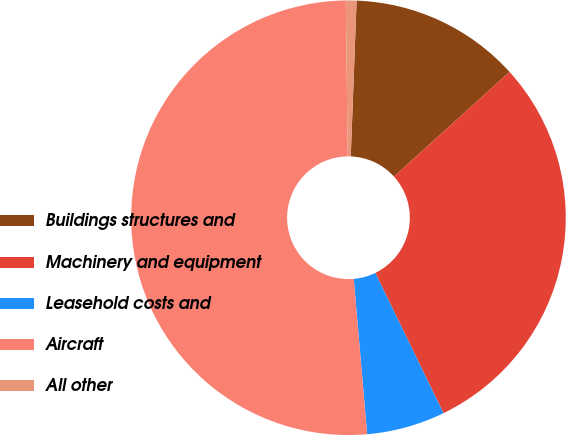<chart> <loc_0><loc_0><loc_500><loc_500><pie_chart><fcel>Buildings structures and<fcel>Machinery and equipment<fcel>Leasehold costs and<fcel>Aircraft<fcel>All other<nl><fcel>12.69%<fcel>29.51%<fcel>5.83%<fcel>51.17%<fcel>0.79%<nl></chart> 